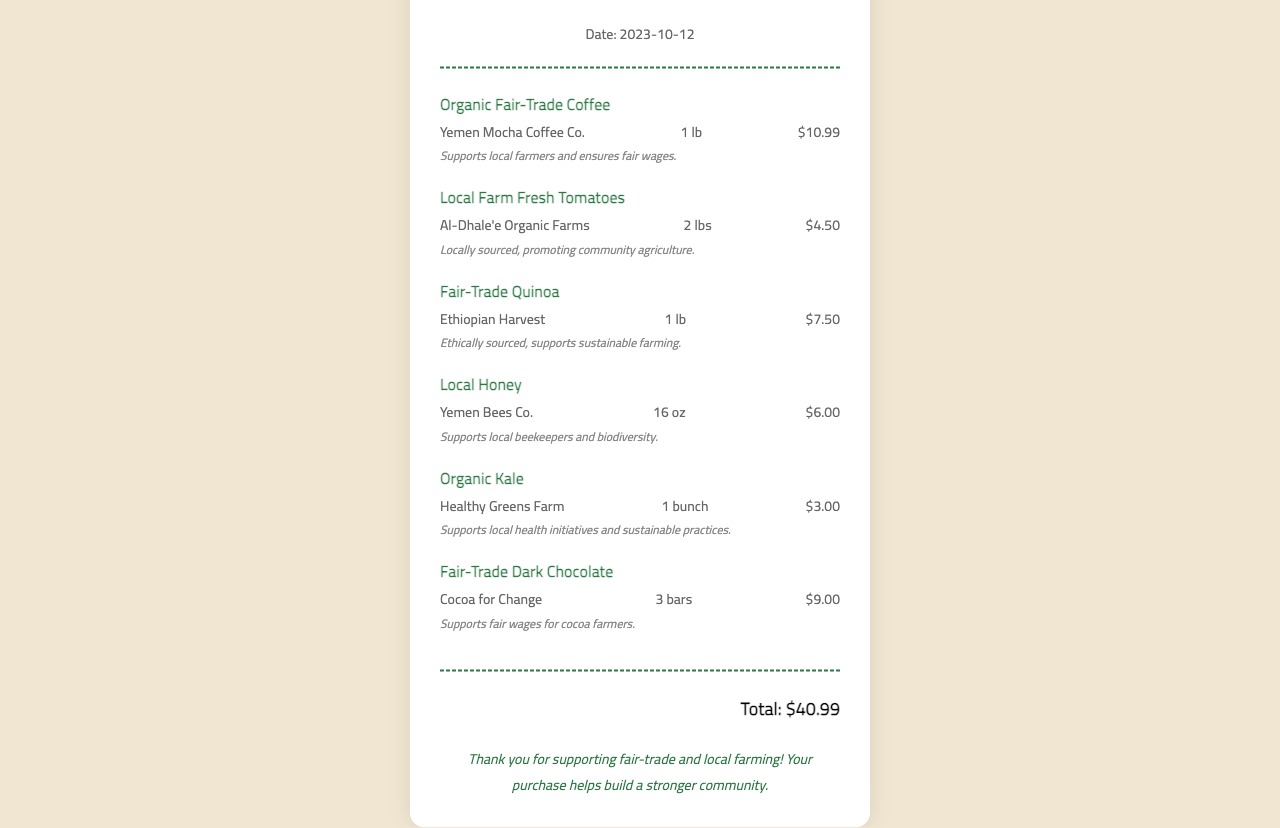What is the name of the store? The store name is prominently displayed at the top of the receipt.
Answer: Green Earth Market What is the purchase date? The purchase date is located above the items section on the receipt.
Answer: 2023-10-12 How many pounds of Local Farm Fresh Tomatoes were purchased? The weight of the tomatoes is stated in the item details section.
Answer: 2 lbs What is the total amount spent? The total amount is found at the bottom of the receipt summarizing the expenditure.
Answer: $40.99 Which item is sourced from Yemen? Referring to the item notes and details, one of the items lists its source.
Answer: Local Honey What is the price of Fair-Trade Quinoa? The price for Fair-Trade Quinoa is indicated in the details of that item.
Answer: $7.50 What does the purchase support according to the notes? The item notes provide information about the social impact of each product purchased.
Answer: Supports local farmers and ensures fair wages How many bars of Fair-Trade Dark Chocolate were bought? The number of bars is mentioned in the item details section specific to that product.
Answer: 3 bars Which farm provides the Organic Kale? The details of the item state the source of the Organic Kale.
Answer: Healthy Greens Farm 